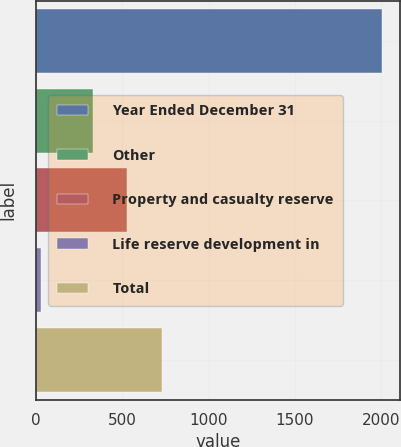Convert chart to OTSL. <chart><loc_0><loc_0><loc_500><loc_500><bar_chart><fcel>Year Ended December 31<fcel>Other<fcel>Property and casualty reserve<fcel>Life reserve development in<fcel>Total<nl><fcel>2006<fcel>332<fcel>529.7<fcel>29<fcel>727.4<nl></chart> 